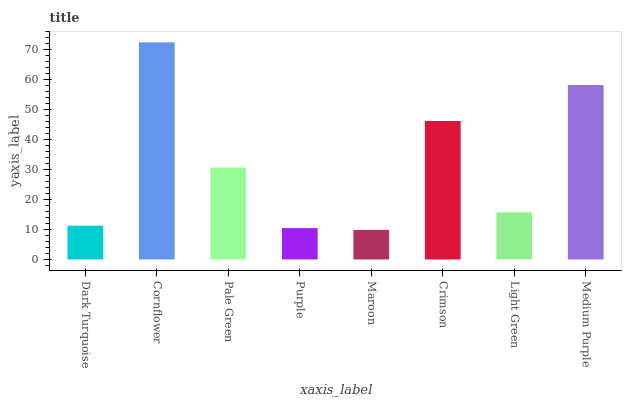Is Maroon the minimum?
Answer yes or no. Yes. Is Cornflower the maximum?
Answer yes or no. Yes. Is Pale Green the minimum?
Answer yes or no. No. Is Pale Green the maximum?
Answer yes or no. No. Is Cornflower greater than Pale Green?
Answer yes or no. Yes. Is Pale Green less than Cornflower?
Answer yes or no. Yes. Is Pale Green greater than Cornflower?
Answer yes or no. No. Is Cornflower less than Pale Green?
Answer yes or no. No. Is Pale Green the high median?
Answer yes or no. Yes. Is Light Green the low median?
Answer yes or no. Yes. Is Dark Turquoise the high median?
Answer yes or no. No. Is Medium Purple the low median?
Answer yes or no. No. 